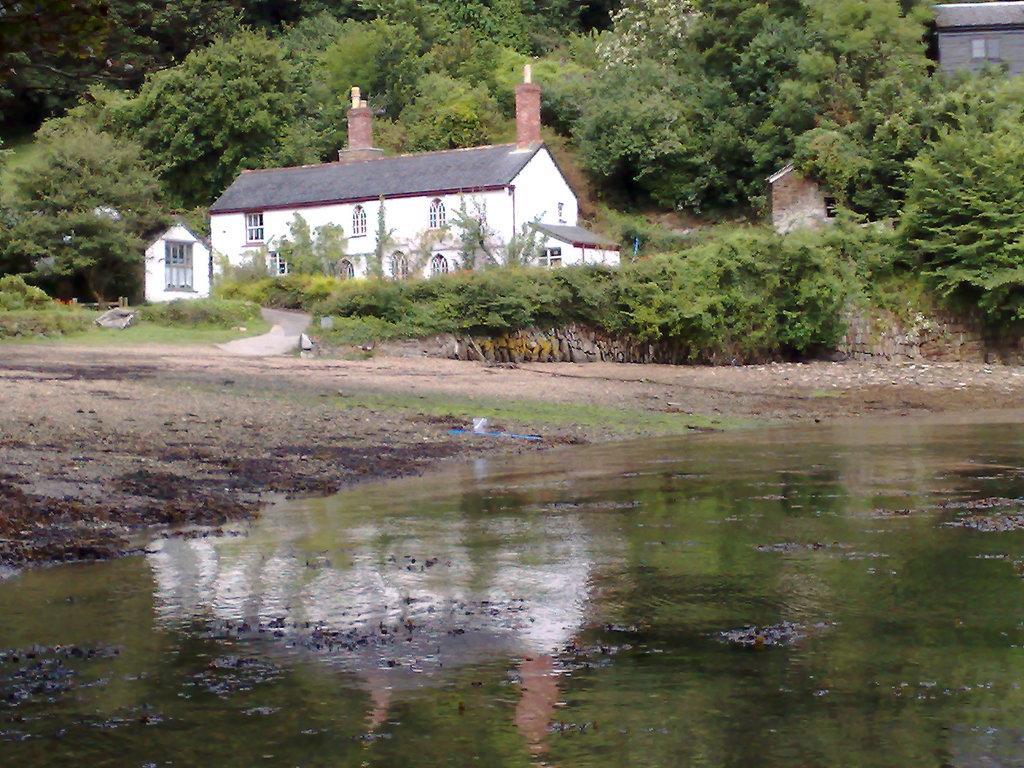In one or two sentences, can you explain what this image depicts? As we can see in the image there is water, planets, houses and trees. 